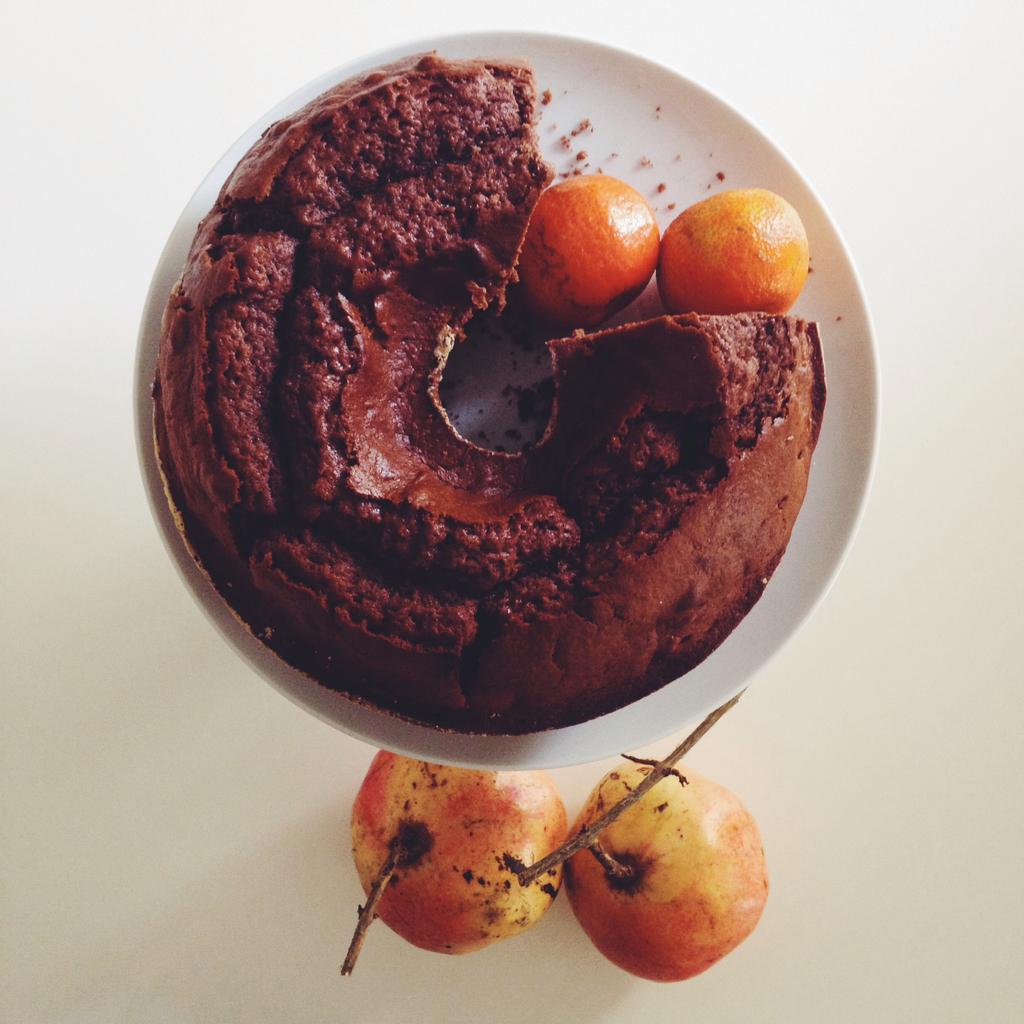Please provide a concise description of this image. In the center of the image we can see one table. On the table, we can see one plate and fruits. In the plate, we can see one cake and oranges. 